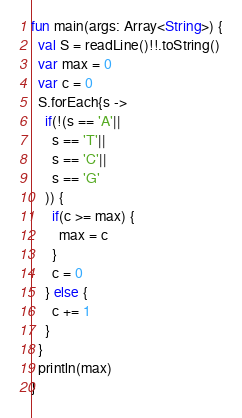Convert code to text. <code><loc_0><loc_0><loc_500><loc_500><_Kotlin_>fun main(args: Array<String>) {
  val S = readLine()!!.toString()
  var max = 0
  var c = 0
  S.forEach{s ->
    if(!(s == 'A'||
      s == 'T'||
      s == 'C'||
      s == 'G'
    )) {
      if(c >= max) {
        max = c
      }
      c = 0
    } else {
      c += 1
    }
  }
  println(max)
}</code> 